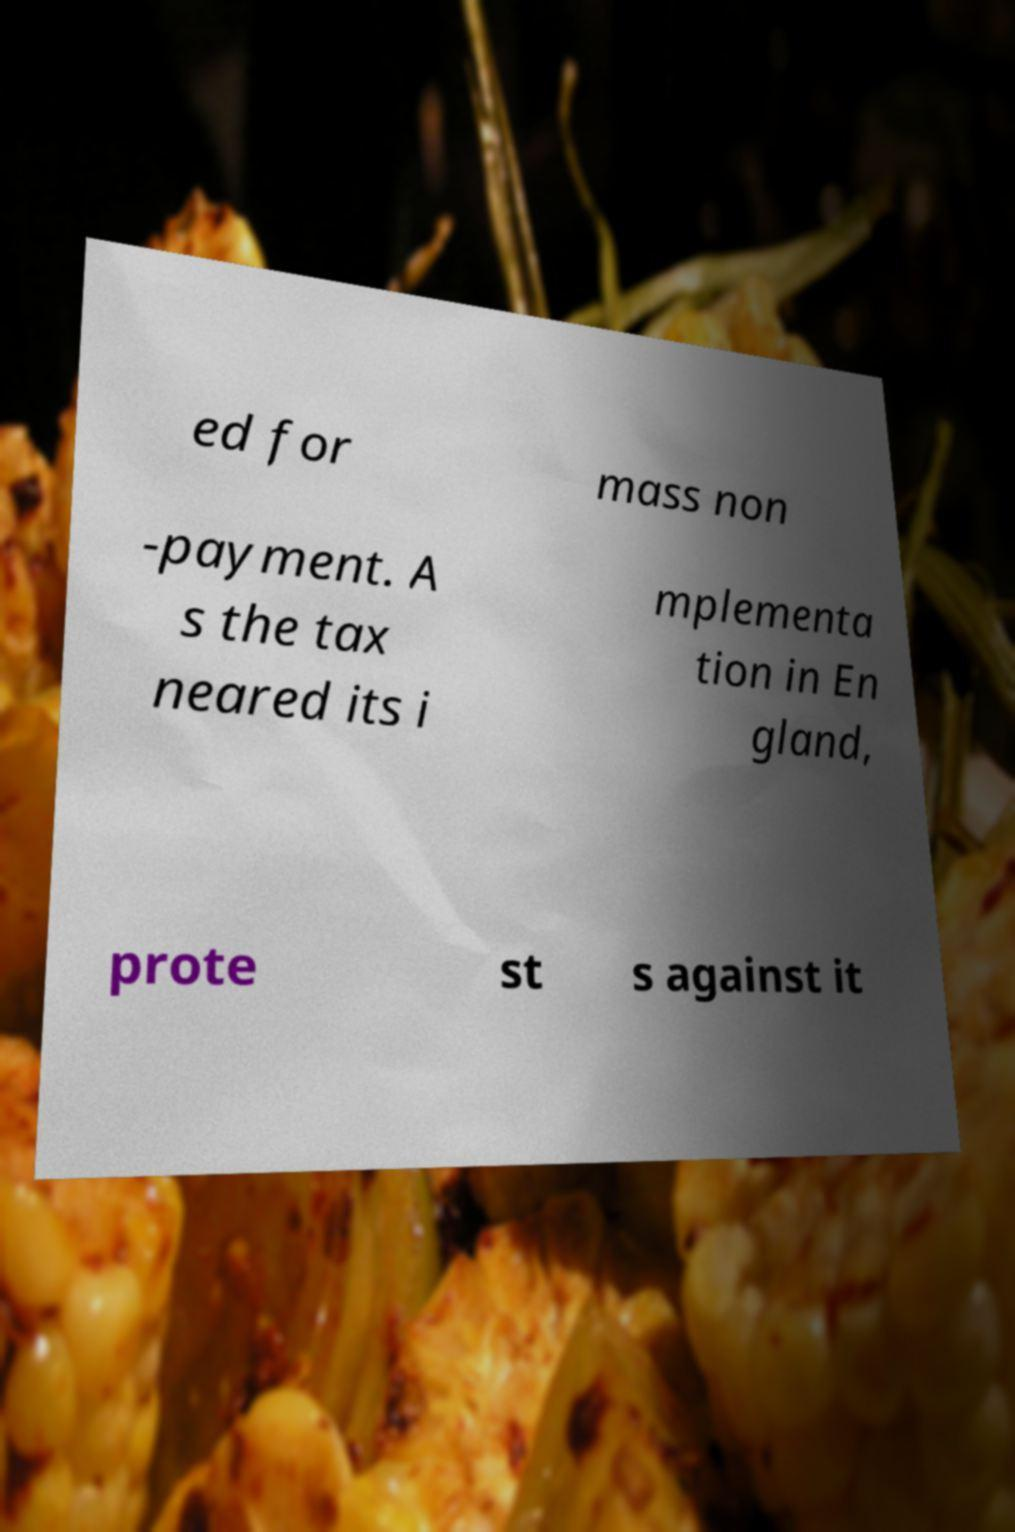Please read and relay the text visible in this image. What does it say? ed for mass non -payment. A s the tax neared its i mplementa tion in En gland, prote st s against it 